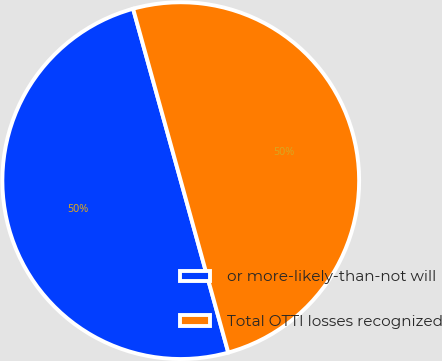Convert chart to OTSL. <chart><loc_0><loc_0><loc_500><loc_500><pie_chart><fcel>or more-likely-than-not will<fcel>Total OTTI losses recognized<nl><fcel>49.99%<fcel>50.01%<nl></chart> 